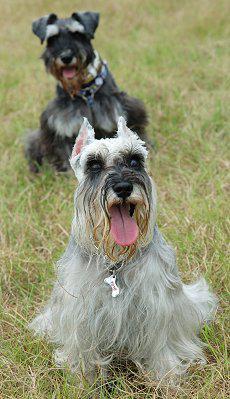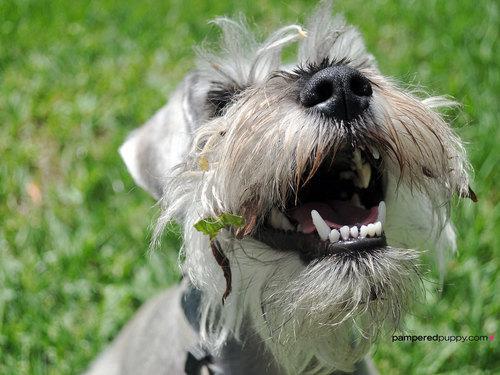The first image is the image on the left, the second image is the image on the right. Considering the images on both sides, is "There is at least collar in the image on the left." valid? Answer yes or no. Yes. 